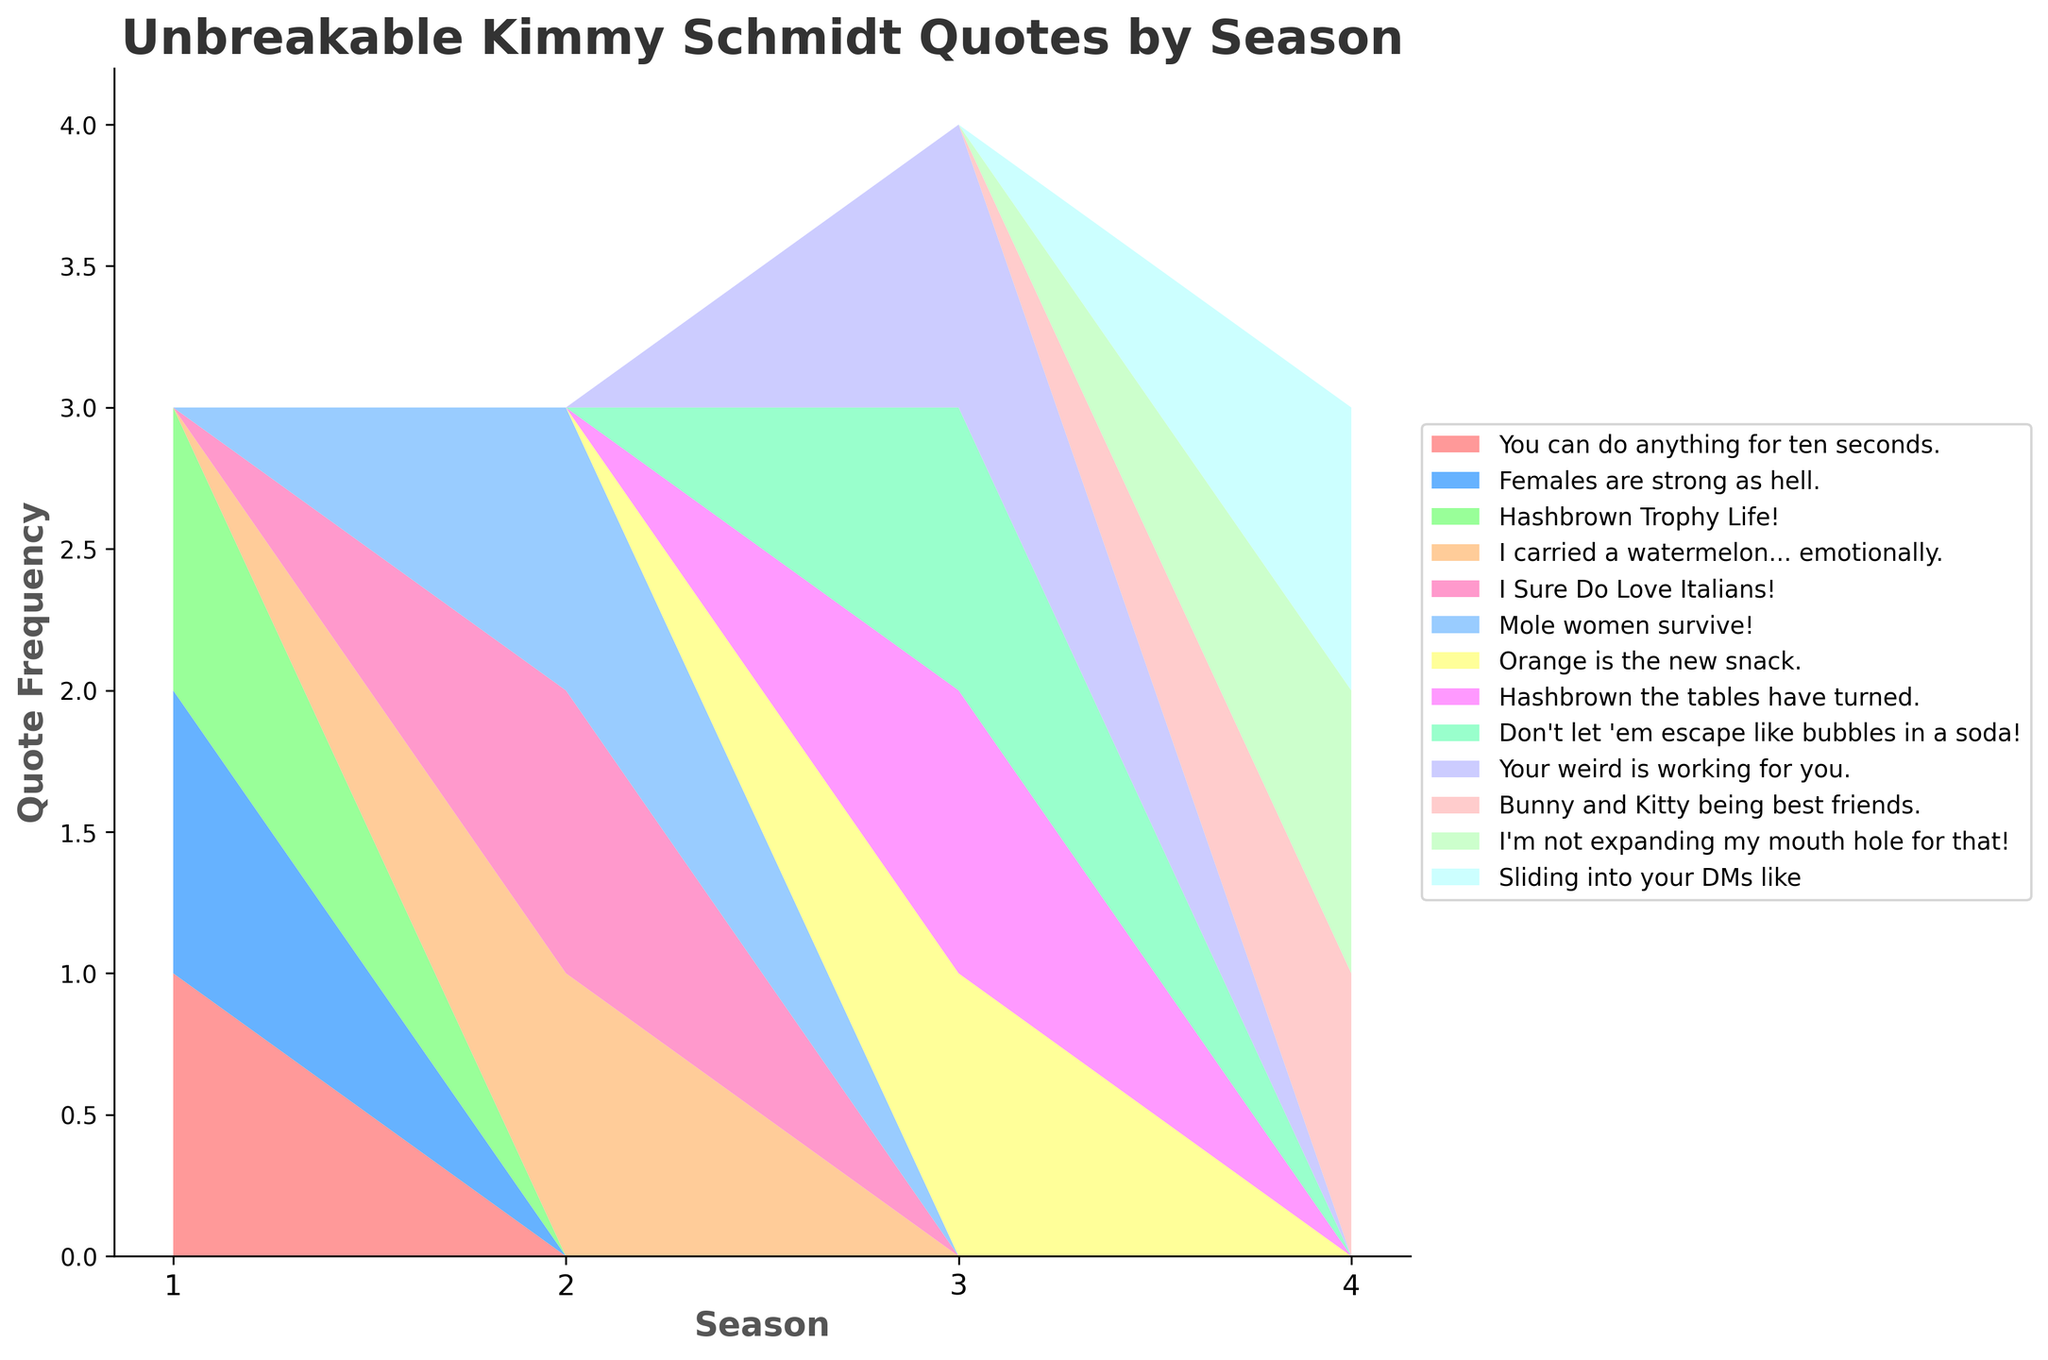What is the title of the plot? The title of the plot is typically shown at the top of the figure, above the main graphical elements. Here, it reads, "Unbreakable Kimmy Schmidt Quotes by Season."
Answer: Unbreakable Kimmy Schmidt Quotes by Season How many seasons are represented in the plot? To find out how many seasons are represented, look at the x-axis where the seasons are usually labeled. Count the number of unique seasons listed.
Answer: 4 Which quote appears the most frequently in Season 1? Observe the stackplot for Season 1 and identify the layer (quote) that has the largest area in that season. The quote "Females are strong as hell" occupies the largest area.
Answer: Females are strong as hell Which season has the highest number of quotes in total? To determine this, compare the combined areas of all the quotes for each season. The season with the highest stack would have the most quotes. Season 3 has the largest combined area.
Answer: Season 3 Are there more quotes in Season 2 or Season 4? By comparing the heights of the stacked areas, observe which season between 2 and 4 has a greater total height. Season 2 has a slightly larger combined height of all quotes.
Answer: Season 2 Which quote first appears in Season 3? Look at the data points plotted for the first episode of Season 3 and identify any quotes that do not appear in prior seasons. "Orange is the new snack" is first seen in Season 3.
Answer: Orange is the new snack How does the frequency of "Hashbrown the tables have turned" compare between Season 3 and other seasons? Identify the area covered by "Hashbrown the tables have turned" in Season 3 and compare it to its area in other seasons. It only appears in Season 3.
Answer: Only appears in Season 3 What is the total frequency of quotes from Season 4? Sum the individual areas (height of layers) of each quote stack in Season 4 to get the total frequency of quotes for that season.
Answer: Sum of areas of all quotes in Season 4 Is "I carried a watermelon... emotionally" more common in Season 2 or Season 3? Compare the area of "I carried a watermelon... emotionally" in Season 2 with any potential area it might occupy in Season 3. It only appears in Season 2.
Answer: Season 2 Which quote appears in multiple seasons? Identify the quotes that have coverage (area) in more than one season. The quote "Hashbrown Trophy Life!" appears across multiple seasons.
Answer: Hashbrown Trophy Life! 